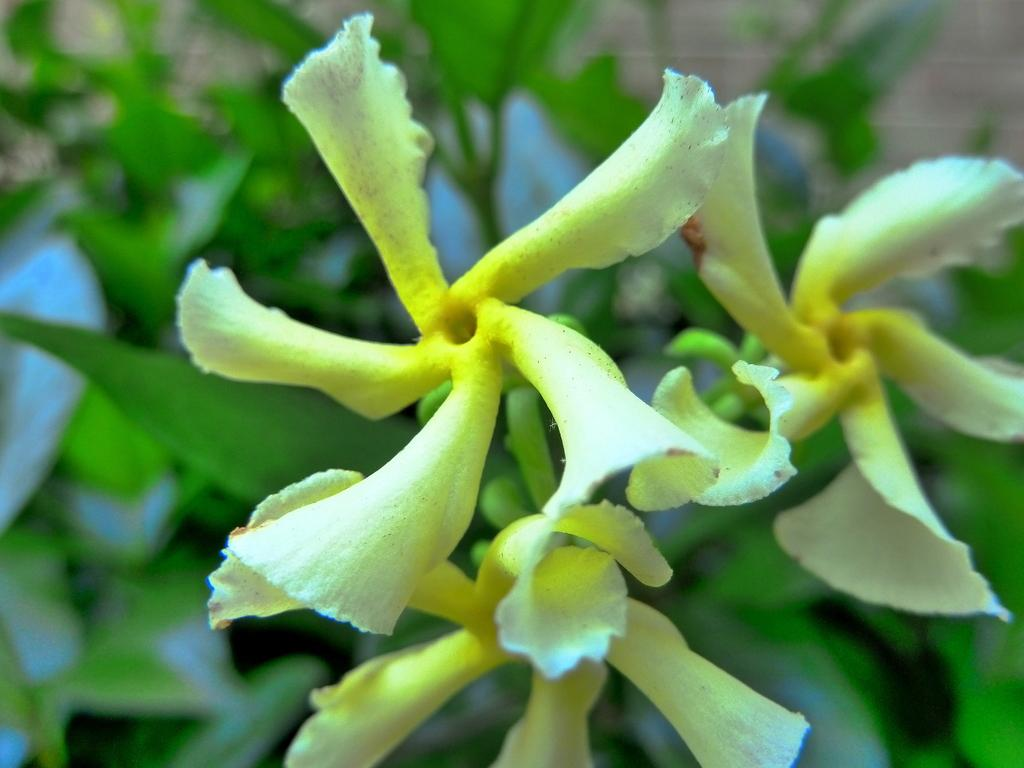What type of plants are in the image? There are flowers in the image. What color are the leaves of the flowers? The flowers have green leaves. Can you describe the background of the image? The background of the image is blurred. What is the taste of the bubble in the image? There is no bubble present in the image, so it is not possible to determine its taste. 